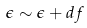Convert formula to latex. <formula><loc_0><loc_0><loc_500><loc_500>\epsilon \sim \epsilon + d f</formula> 